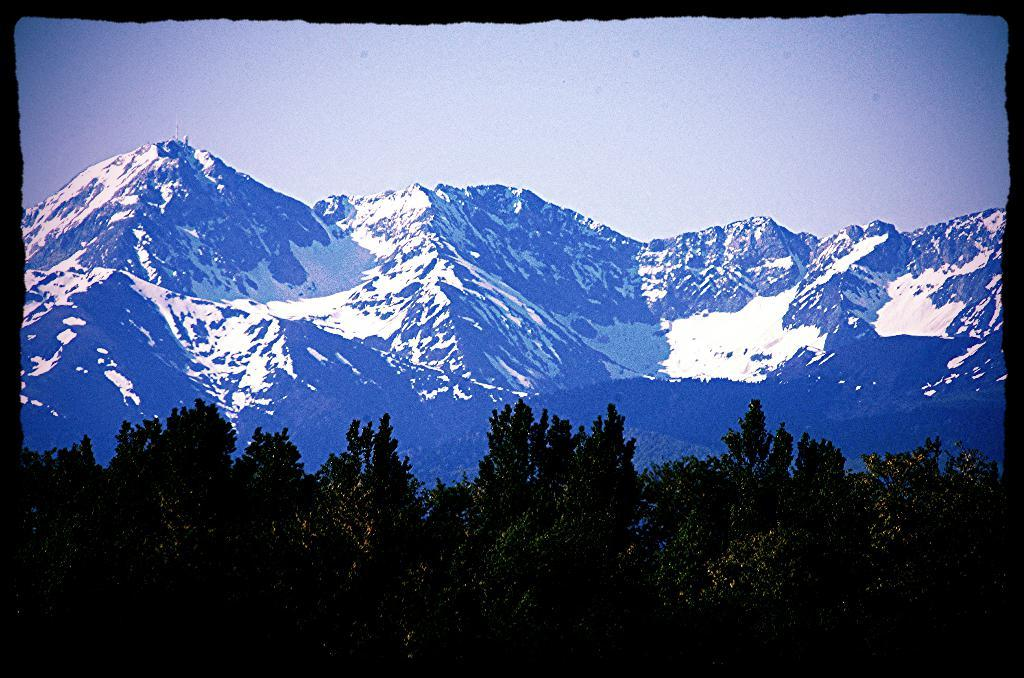What type of vegetation is present at the bottom of the image? There are trees at the bottom side of the image. What type of geographical feature can be seen in the background of the image? There are snow mountains in the background area of the image. What color crayon is being used to draw the trees in the image? There is no crayon present in the image; the trees are depicted as they naturally appear. What type of feast is being prepared in the snow mountains in the image? There is no feast or indication of food preparation in the image; it only features trees at the bottom and snow mountains in the background. 